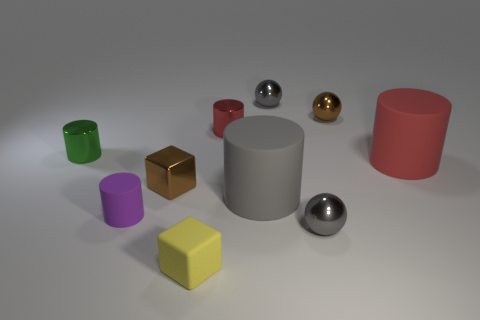Subtract all gray cylinders. How many cylinders are left? 4 Subtract all cyan cubes. How many gray spheres are left? 2 Subtract all spheres. How many objects are left? 7 Subtract all blue balls. Subtract all brown blocks. How many balls are left? 3 Subtract all gray metallic balls. Subtract all purple rubber cylinders. How many objects are left? 7 Add 6 rubber things. How many rubber things are left? 10 Add 8 tiny brown balls. How many tiny brown balls exist? 9 Subtract all brown balls. How many balls are left? 2 Subtract 1 gray spheres. How many objects are left? 9 Subtract 1 blocks. How many blocks are left? 1 